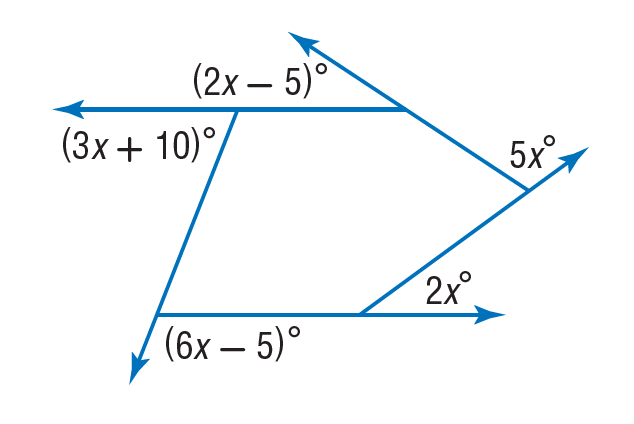Question: Find the value of x in the diagram.
Choices:
A. 5
B. 10
C. 20
D. 40
Answer with the letter. Answer: C 